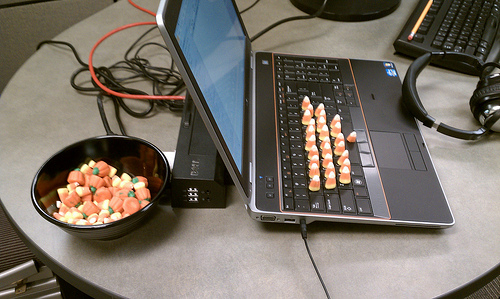<image>
Can you confirm if the sweets is under the keyboard? No. The sweets is not positioned under the keyboard. The vertical relationship between these objects is different. Where is the candy in relation to the laptop? Is it on the laptop? Yes. Looking at the image, I can see the candy is positioned on top of the laptop, with the laptop providing support. 